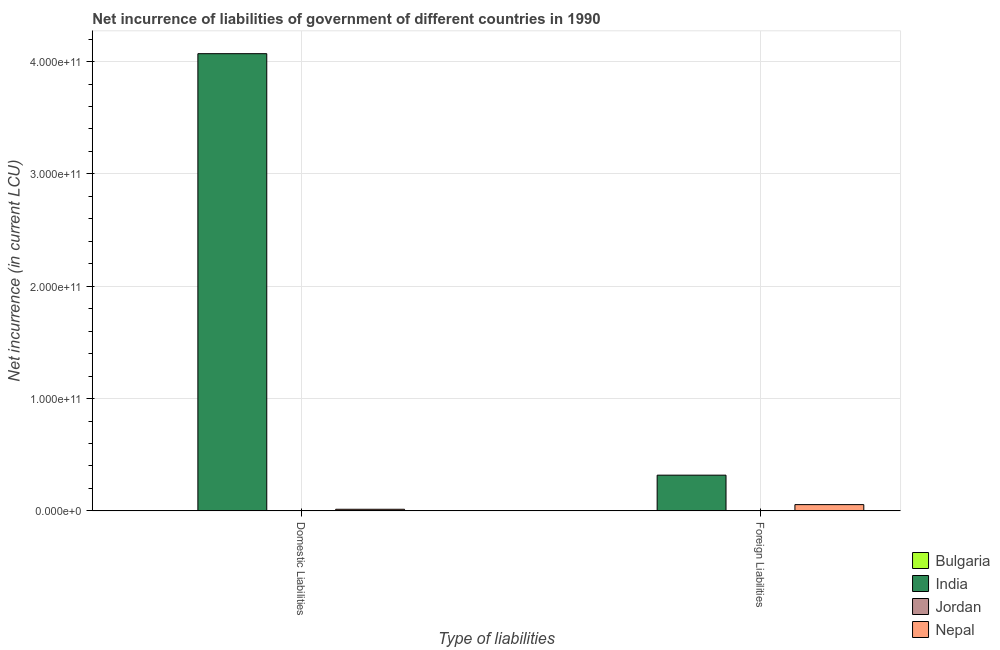How many different coloured bars are there?
Your answer should be compact. 4. How many bars are there on the 1st tick from the left?
Offer a very short reply. 4. What is the label of the 1st group of bars from the left?
Make the answer very short. Domestic Liabilities. What is the net incurrence of foreign liabilities in Nepal?
Your answer should be compact. 5.58e+09. Across all countries, what is the maximum net incurrence of foreign liabilities?
Your answer should be very brief. 3.18e+1. Across all countries, what is the minimum net incurrence of domestic liabilities?
Make the answer very short. 4.09e+06. What is the total net incurrence of domestic liabilities in the graph?
Your answer should be compact. 4.08e+11. What is the difference between the net incurrence of domestic liabilities in India and that in Nepal?
Keep it short and to the point. 4.06e+11. What is the difference between the net incurrence of foreign liabilities in India and the net incurrence of domestic liabilities in Jordan?
Your response must be concise. 3.18e+1. What is the average net incurrence of foreign liabilities per country?
Provide a succinct answer. 9.38e+09. What is the difference between the net incurrence of domestic liabilities and net incurrence of foreign liabilities in India?
Keep it short and to the point. 3.75e+11. In how many countries, is the net incurrence of domestic liabilities greater than 320000000000 LCU?
Offer a very short reply. 1. What is the ratio of the net incurrence of foreign liabilities in Jordan to that in Nepal?
Provide a short and direct response. 0.02. Is the net incurrence of domestic liabilities in Jordan less than that in Bulgaria?
Your response must be concise. No. In how many countries, is the net incurrence of foreign liabilities greater than the average net incurrence of foreign liabilities taken over all countries?
Your answer should be very brief. 1. How many countries are there in the graph?
Ensure brevity in your answer.  4. What is the difference between two consecutive major ticks on the Y-axis?
Ensure brevity in your answer.  1.00e+11. Where does the legend appear in the graph?
Your response must be concise. Bottom right. How are the legend labels stacked?
Offer a very short reply. Vertical. What is the title of the graph?
Keep it short and to the point. Net incurrence of liabilities of government of different countries in 1990. What is the label or title of the X-axis?
Provide a succinct answer. Type of liabilities. What is the label or title of the Y-axis?
Give a very brief answer. Net incurrence (in current LCU). What is the Net incurrence (in current LCU) in Bulgaria in Domestic Liabilities?
Keep it short and to the point. 4.09e+06. What is the Net incurrence (in current LCU) of India in Domestic Liabilities?
Offer a terse response. 4.07e+11. What is the Net incurrence (in current LCU) in Jordan in Domestic Liabilities?
Offer a very short reply. 4.87e+07. What is the Net incurrence (in current LCU) of Nepal in Domestic Liabilities?
Make the answer very short. 1.43e+09. What is the Net incurrence (in current LCU) in Bulgaria in Foreign Liabilities?
Provide a short and direct response. 0. What is the Net incurrence (in current LCU) of India in Foreign Liabilities?
Provide a short and direct response. 3.18e+1. What is the Net incurrence (in current LCU) in Jordan in Foreign Liabilities?
Provide a short and direct response. 1.30e+08. What is the Net incurrence (in current LCU) of Nepal in Foreign Liabilities?
Offer a very short reply. 5.58e+09. Across all Type of liabilities, what is the maximum Net incurrence (in current LCU) of Bulgaria?
Your response must be concise. 4.09e+06. Across all Type of liabilities, what is the maximum Net incurrence (in current LCU) of India?
Offer a very short reply. 4.07e+11. Across all Type of liabilities, what is the maximum Net incurrence (in current LCU) of Jordan?
Your answer should be compact. 1.30e+08. Across all Type of liabilities, what is the maximum Net incurrence (in current LCU) in Nepal?
Provide a short and direct response. 5.58e+09. Across all Type of liabilities, what is the minimum Net incurrence (in current LCU) in Bulgaria?
Provide a short and direct response. 0. Across all Type of liabilities, what is the minimum Net incurrence (in current LCU) in India?
Your answer should be very brief. 3.18e+1. Across all Type of liabilities, what is the minimum Net incurrence (in current LCU) in Jordan?
Your answer should be very brief. 4.87e+07. Across all Type of liabilities, what is the minimum Net incurrence (in current LCU) of Nepal?
Provide a short and direct response. 1.43e+09. What is the total Net incurrence (in current LCU) in Bulgaria in the graph?
Offer a terse response. 4.09e+06. What is the total Net incurrence (in current LCU) in India in the graph?
Keep it short and to the point. 4.39e+11. What is the total Net incurrence (in current LCU) in Jordan in the graph?
Your answer should be compact. 1.78e+08. What is the total Net incurrence (in current LCU) in Nepal in the graph?
Give a very brief answer. 7.01e+09. What is the difference between the Net incurrence (in current LCU) in India in Domestic Liabilities and that in Foreign Liabilities?
Provide a succinct answer. 3.75e+11. What is the difference between the Net incurrence (in current LCU) in Jordan in Domestic Liabilities and that in Foreign Liabilities?
Your answer should be very brief. -8.10e+07. What is the difference between the Net incurrence (in current LCU) in Nepal in Domestic Liabilities and that in Foreign Liabilities?
Offer a very short reply. -4.15e+09. What is the difference between the Net incurrence (in current LCU) of Bulgaria in Domestic Liabilities and the Net incurrence (in current LCU) of India in Foreign Liabilities?
Your response must be concise. -3.18e+1. What is the difference between the Net incurrence (in current LCU) in Bulgaria in Domestic Liabilities and the Net incurrence (in current LCU) in Jordan in Foreign Liabilities?
Offer a terse response. -1.26e+08. What is the difference between the Net incurrence (in current LCU) in Bulgaria in Domestic Liabilities and the Net incurrence (in current LCU) in Nepal in Foreign Liabilities?
Your answer should be very brief. -5.58e+09. What is the difference between the Net incurrence (in current LCU) in India in Domestic Liabilities and the Net incurrence (in current LCU) in Jordan in Foreign Liabilities?
Your answer should be very brief. 4.07e+11. What is the difference between the Net incurrence (in current LCU) of India in Domestic Liabilities and the Net incurrence (in current LCU) of Nepal in Foreign Liabilities?
Your answer should be compact. 4.01e+11. What is the difference between the Net incurrence (in current LCU) in Jordan in Domestic Liabilities and the Net incurrence (in current LCU) in Nepal in Foreign Liabilities?
Your response must be concise. -5.53e+09. What is the average Net incurrence (in current LCU) of Bulgaria per Type of liabilities?
Your answer should be very brief. 2.05e+06. What is the average Net incurrence (in current LCU) in India per Type of liabilities?
Your answer should be very brief. 2.19e+11. What is the average Net incurrence (in current LCU) in Jordan per Type of liabilities?
Offer a terse response. 8.92e+07. What is the average Net incurrence (in current LCU) in Nepal per Type of liabilities?
Your answer should be very brief. 3.51e+09. What is the difference between the Net incurrence (in current LCU) in Bulgaria and Net incurrence (in current LCU) in India in Domestic Liabilities?
Offer a very short reply. -4.07e+11. What is the difference between the Net incurrence (in current LCU) of Bulgaria and Net incurrence (in current LCU) of Jordan in Domestic Liabilities?
Your response must be concise. -4.46e+07. What is the difference between the Net incurrence (in current LCU) in Bulgaria and Net incurrence (in current LCU) in Nepal in Domestic Liabilities?
Make the answer very short. -1.43e+09. What is the difference between the Net incurrence (in current LCU) in India and Net incurrence (in current LCU) in Jordan in Domestic Liabilities?
Give a very brief answer. 4.07e+11. What is the difference between the Net incurrence (in current LCU) of India and Net incurrence (in current LCU) of Nepal in Domestic Liabilities?
Offer a terse response. 4.06e+11. What is the difference between the Net incurrence (in current LCU) of Jordan and Net incurrence (in current LCU) of Nepal in Domestic Liabilities?
Give a very brief answer. -1.38e+09. What is the difference between the Net incurrence (in current LCU) in India and Net incurrence (in current LCU) in Jordan in Foreign Liabilities?
Ensure brevity in your answer.  3.17e+1. What is the difference between the Net incurrence (in current LCU) in India and Net incurrence (in current LCU) in Nepal in Foreign Liabilities?
Ensure brevity in your answer.  2.62e+1. What is the difference between the Net incurrence (in current LCU) of Jordan and Net incurrence (in current LCU) of Nepal in Foreign Liabilities?
Ensure brevity in your answer.  -5.45e+09. What is the ratio of the Net incurrence (in current LCU) in India in Domestic Liabilities to that in Foreign Liabilities?
Provide a short and direct response. 12.8. What is the ratio of the Net incurrence (in current LCU) in Jordan in Domestic Liabilities to that in Foreign Liabilities?
Provide a short and direct response. 0.38. What is the ratio of the Net incurrence (in current LCU) in Nepal in Domestic Liabilities to that in Foreign Liabilities?
Your answer should be very brief. 0.26. What is the difference between the highest and the second highest Net incurrence (in current LCU) of India?
Provide a succinct answer. 3.75e+11. What is the difference between the highest and the second highest Net incurrence (in current LCU) of Jordan?
Provide a short and direct response. 8.10e+07. What is the difference between the highest and the second highest Net incurrence (in current LCU) in Nepal?
Your answer should be very brief. 4.15e+09. What is the difference between the highest and the lowest Net incurrence (in current LCU) in Bulgaria?
Your answer should be very brief. 4.09e+06. What is the difference between the highest and the lowest Net incurrence (in current LCU) of India?
Provide a short and direct response. 3.75e+11. What is the difference between the highest and the lowest Net incurrence (in current LCU) in Jordan?
Keep it short and to the point. 8.10e+07. What is the difference between the highest and the lowest Net incurrence (in current LCU) in Nepal?
Your answer should be very brief. 4.15e+09. 